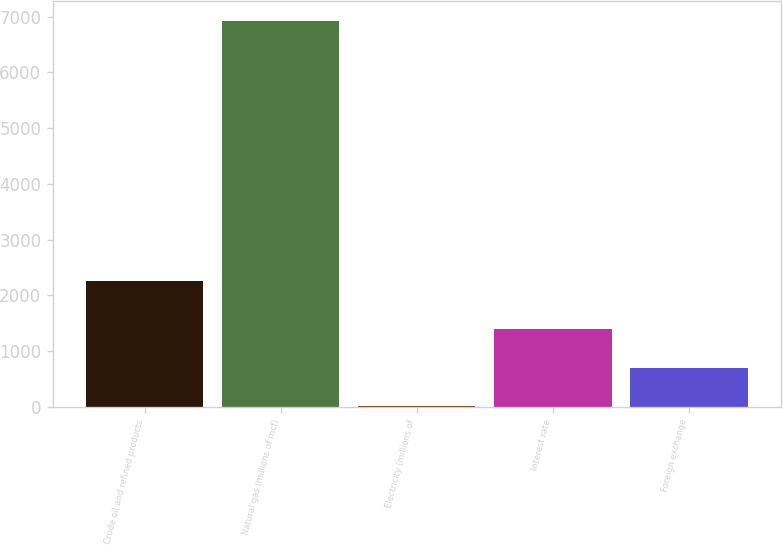Convert chart to OTSL. <chart><loc_0><loc_0><loc_500><loc_500><bar_chart><fcel>Crude oil and refined products<fcel>Natural gas (millions of mcf)<fcel>Electricity (millions of<fcel>Interest rate<fcel>Foreign exchange<nl><fcel>2251<fcel>6927<fcel>6<fcel>1390.2<fcel>698.1<nl></chart> 